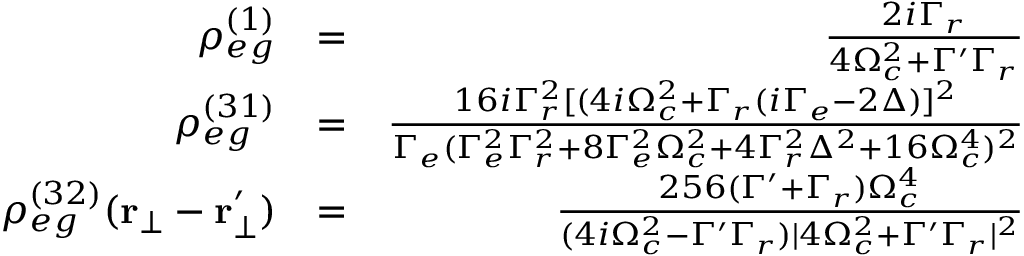<formula> <loc_0><loc_0><loc_500><loc_500>\begin{array} { r l r } { \rho _ { e g } ^ { ( 1 ) } } & { = } & { \frac { 2 i \Gamma _ { r } } { 4 \Omega _ { c } ^ { 2 } + \Gamma ^ { \prime } \Gamma _ { r } } } \\ { \rho _ { e g } ^ { ( 3 1 ) } } & { = } & { \frac { 1 6 i \Gamma _ { r } ^ { 2 } [ ( 4 i \Omega _ { c } ^ { 2 } + \Gamma _ { r } ( i \Gamma _ { e } - 2 \Delta ) ] ^ { 2 } } { \Gamma _ { e } ( \Gamma _ { e } ^ { 2 } \Gamma _ { r } ^ { 2 } + 8 \Gamma _ { e } ^ { 2 } \Omega _ { c } ^ { 2 } + 4 \Gamma _ { r } ^ { 2 } \Delta ^ { 2 } + 1 6 \Omega _ { c } ^ { 4 } ) ^ { 2 } } } \\ { \rho _ { e g } ^ { ( 3 2 ) } ( r _ { \bot } - r _ { \bot } ^ { \prime } ) } & { = } & { \frac { 2 5 6 ( \Gamma ^ { \prime } + \Gamma _ { r } ) \Omega _ { c } ^ { 4 } } { ( 4 i \Omega _ { c } ^ { 2 } - \Gamma ^ { \prime } \Gamma _ { r } ) | 4 \Omega _ { c } ^ { 2 } + \Gamma ^ { \prime } \Gamma _ { r } | ^ { 2 } } } \end{array}</formula> 